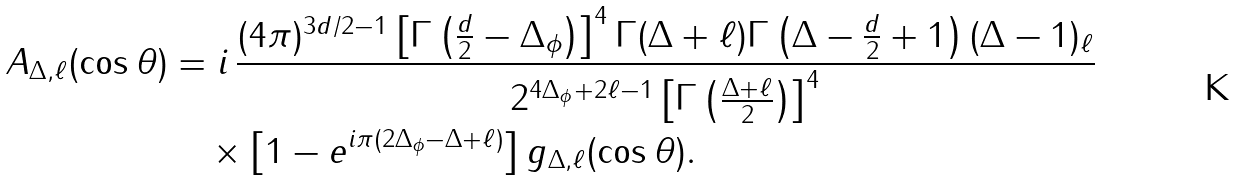<formula> <loc_0><loc_0><loc_500><loc_500>A _ { \Delta , \ell } ( \cos \theta ) & = i \, \frac { ( 4 \pi ) ^ { 3 d / 2 - 1 } \left [ \Gamma \left ( \frac { d } { 2 } - \Delta _ { \phi } \right ) \right ] ^ { 4 } \Gamma ( \Delta + \ell ) \Gamma \left ( \Delta - \frac { d } { 2 } + 1 \right ) ( \Delta - 1 ) _ { \ell } } { 2 ^ { 4 \Delta _ { \phi } + 2 \ell - 1 } \left [ \Gamma \left ( \frac { \Delta + \ell } { 2 } \right ) \right ] ^ { 4 } } \\ & \quad \times \left [ 1 - e ^ { i \pi ( 2 \Delta _ { \phi } - \Delta + \ell ) } \right ] g _ { \Delta , \ell } ( \cos \theta ) .</formula> 